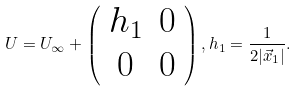Convert formula to latex. <formula><loc_0><loc_0><loc_500><loc_500>U = U _ { \infty } + \left ( \begin{array} { c c } h _ { 1 } & 0 \\ 0 & 0 \end{array} \right ) , h _ { 1 } = \frac { 1 } { 2 | \vec { x } _ { 1 } | } .</formula> 